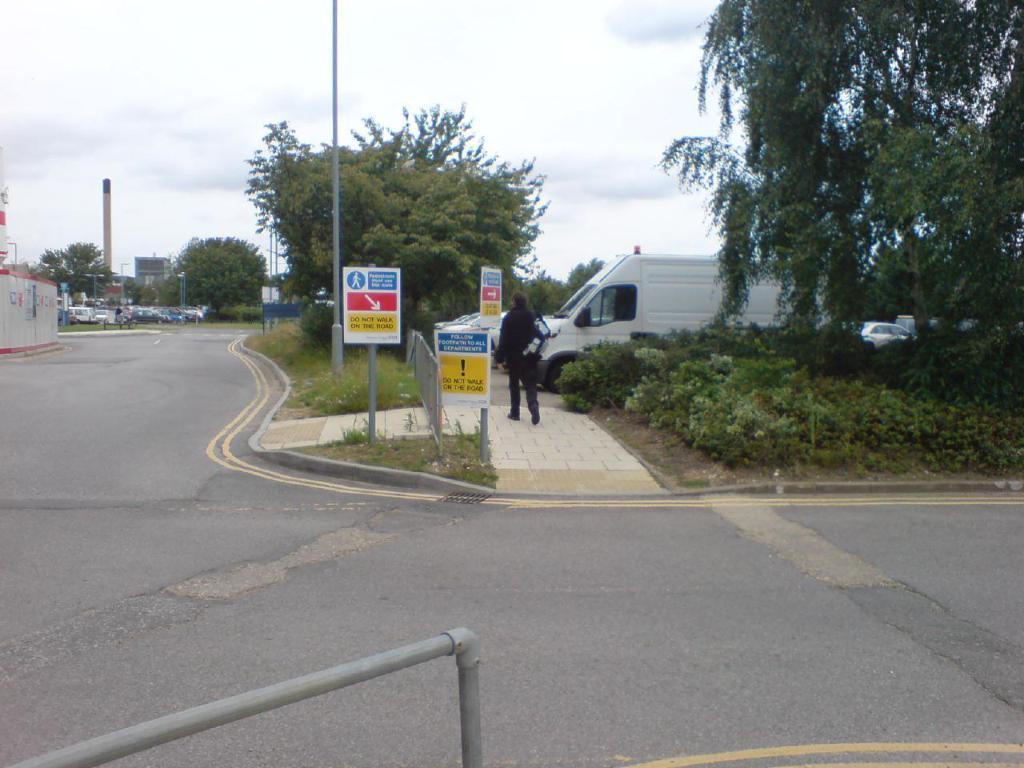Describe this image in one or two sentences. In this image I can see the person walking and I can also see few vehicles, trees, few poles, boards and the sky is in white color. 